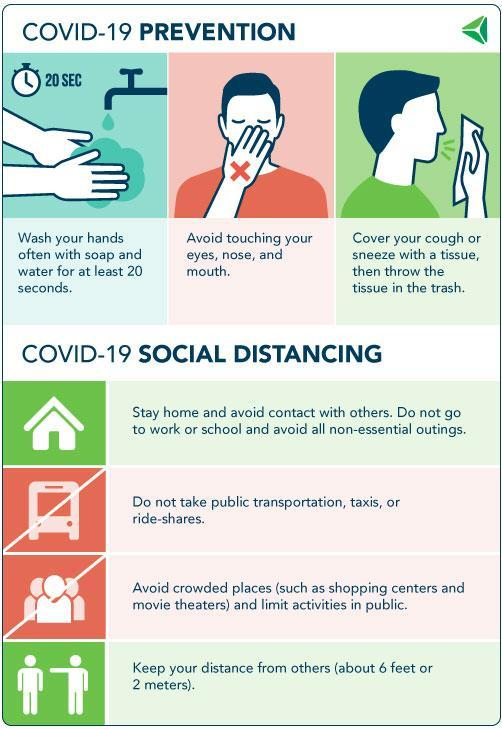Which are the body parts that you should not touch to prevent corona?
Answer the question with a short phrase. eyes, nose, and mouth How many corona preventive measures are listed in the infographic? 3 How long you should clean your hands? 20 seconds 